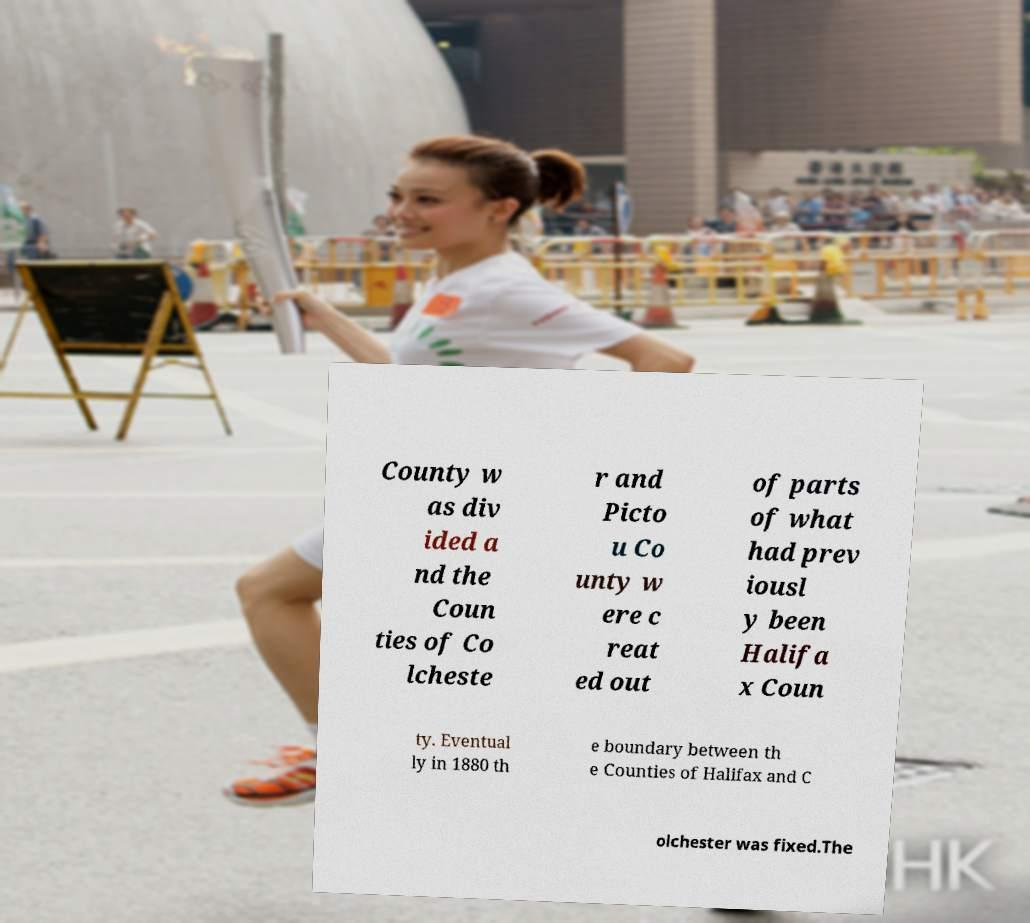What messages or text are displayed in this image? I need them in a readable, typed format. County w as div ided a nd the Coun ties of Co lcheste r and Picto u Co unty w ere c reat ed out of parts of what had prev iousl y been Halifa x Coun ty. Eventual ly in 1880 th e boundary between th e Counties of Halifax and C olchester was fixed.The 